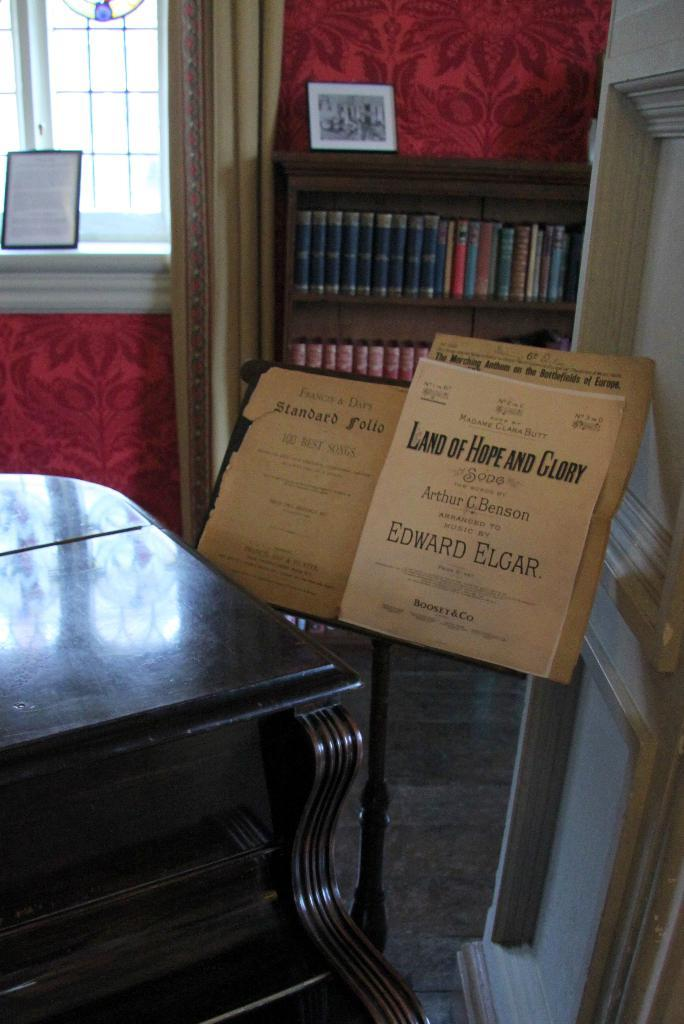<image>
Relay a brief, clear account of the picture shown. A cardboard box with the words "Land of Hope and Glory" on it 